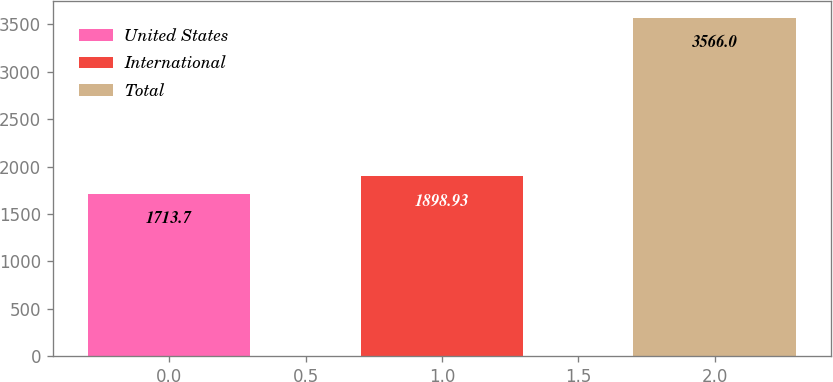Convert chart. <chart><loc_0><loc_0><loc_500><loc_500><bar_chart><fcel>United States<fcel>International<fcel>Total<nl><fcel>1713.7<fcel>1898.93<fcel>3566<nl></chart> 